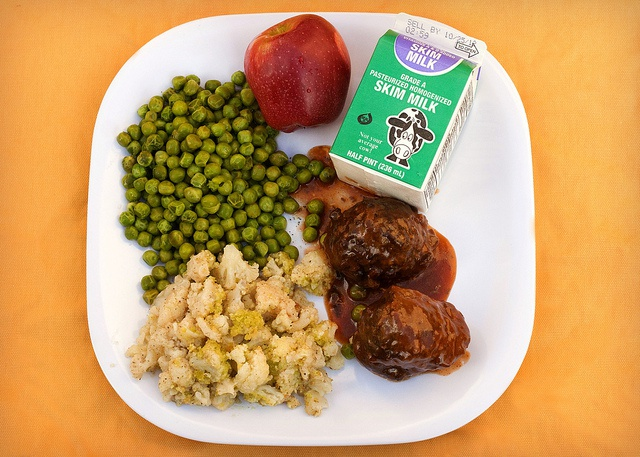Describe the objects in this image and their specific colors. I can see dining table in orange, white, maroon, and olive tones and apple in orange, brown, maroon, and red tones in this image. 